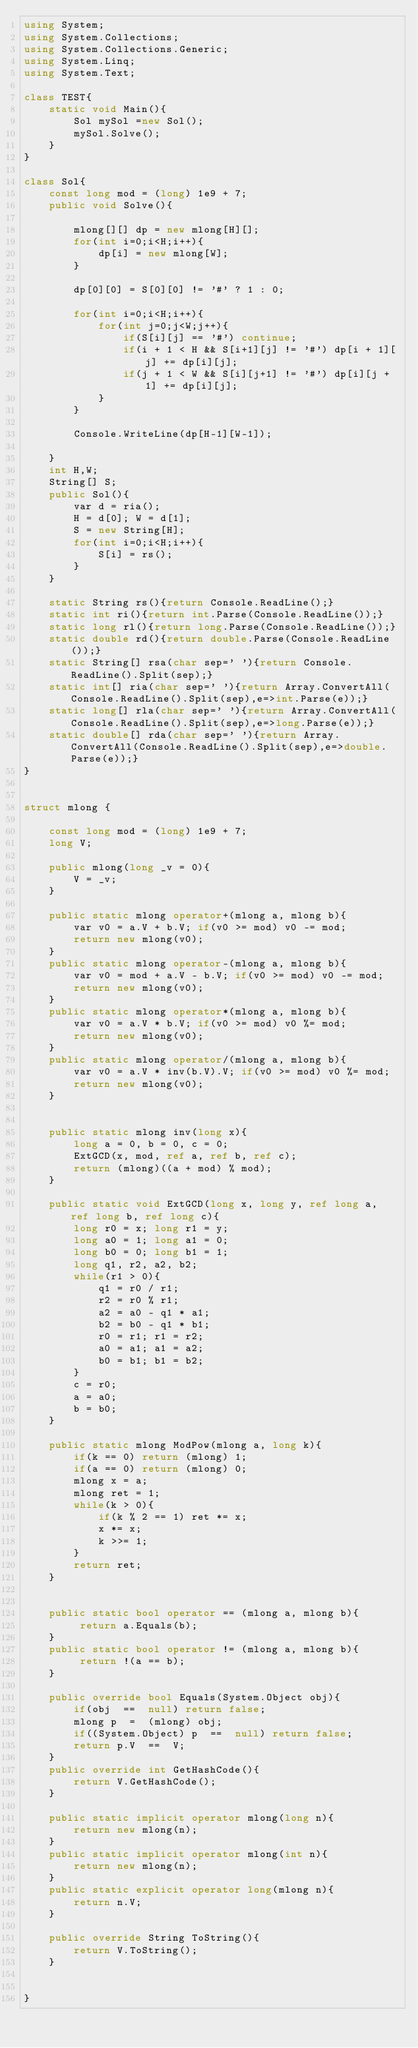<code> <loc_0><loc_0><loc_500><loc_500><_C#_>using System;
using System.Collections;
using System.Collections.Generic;
using System.Linq;
using System.Text;

class TEST{
	static void Main(){
		Sol mySol =new Sol();
		mySol.Solve();
	}
}

class Sol{
	const long mod = (long) 1e9 + 7;
	public void Solve(){
		
		mlong[][] dp = new mlong[H][];
		for(int i=0;i<H;i++){
			dp[i] = new mlong[W];
		}
		
		dp[0][0] = S[0][0] != '#' ? 1 : 0;
		
		for(int i=0;i<H;i++){
			for(int j=0;j<W;j++){
				if(S[i][j] == '#') continue;
				if(i + 1 < H && S[i+1][j] != '#') dp[i + 1][j] += dp[i][j];
				if(j + 1 < W && S[i][j+1] != '#') dp[i][j + 1] += dp[i][j];
			}
		}
		
		Console.WriteLine(dp[H-1][W-1]);
		
	}
	int H,W;
	String[] S;
	public Sol(){
		var d = ria();
		H = d[0]; W = d[1];
		S = new String[H];
		for(int i=0;i<H;i++){
			S[i] = rs();
		}
	}

	static String rs(){return Console.ReadLine();}
	static int ri(){return int.Parse(Console.ReadLine());}
	static long rl(){return long.Parse(Console.ReadLine());}
	static double rd(){return double.Parse(Console.ReadLine());}
	static String[] rsa(char sep=' '){return Console.ReadLine().Split(sep);}
	static int[] ria(char sep=' '){return Array.ConvertAll(Console.ReadLine().Split(sep),e=>int.Parse(e));}
	static long[] rla(char sep=' '){return Array.ConvertAll(Console.ReadLine().Split(sep),e=>long.Parse(e));}
	static double[] rda(char sep=' '){return Array.ConvertAll(Console.ReadLine().Split(sep),e=>double.Parse(e));}
}


struct mlong {
	
	const long mod = (long) 1e9 + 7;
	long V;
	
	public mlong(long _v = 0){
		V = _v;
	}
	
	public static mlong operator+(mlong a, mlong b){
		var v0 = a.V + b.V; if(v0 >= mod) v0 -= mod;
		return new mlong(v0);
	}
	public static mlong operator-(mlong a, mlong b){
		var v0 = mod + a.V - b.V; if(v0 >= mod) v0 -= mod;
		return new mlong(v0);
	}
	public static mlong operator*(mlong a, mlong b){
		var v0 = a.V * b.V; if(v0 >= mod) v0 %= mod;
		return new mlong(v0);
	}
	public static mlong operator/(mlong a, mlong b){
		var v0 = a.V * inv(b.V).V; if(v0 >= mod) v0 %= mod;
		return new mlong(v0);
	}
	
	
	public static mlong inv(long x){
		long a = 0, b = 0, c = 0;
		ExtGCD(x, mod, ref a, ref b, ref c);
		return (mlong)((a + mod) % mod);
	}
	
	public static void ExtGCD(long x, long y, ref long a, ref long b, ref long c){
		long r0 = x; long r1 = y;
		long a0 = 1; long a1 = 0;
		long b0 = 0; long b1 = 1;
		long q1, r2, a2, b2;
		while(r1 > 0){
			q1 = r0 / r1;
			r2 = r0 % r1;
			a2 = a0 - q1 * a1;
			b2 = b0 - q1 * b1;
			r0 = r1; r1 = r2;
			a0 = a1; a1 = a2;
			b0 = b1; b1 = b2;
		}
		c = r0;
		a = a0;
		b = b0;
	}
	
	public static mlong ModPow(mlong a, long k){
		if(k == 0) return (mlong) 1;
		if(a == 0) return (mlong) 0;
		mlong x = a;
		mlong ret = 1;
		while(k > 0){
			if(k % 2 == 1) ret *= x;
			x *= x;
			k >>= 1;
		}
		return ret;
	}
	
	
	public static bool operator == (mlong a, mlong b){
		 return a.Equals(b);
	}
	public static bool operator != (mlong a, mlong b){
		 return !(a == b);
	}
	
	public override bool Equals(System.Object obj){
		if(obj  ==  null) return false;
		mlong p  =  (mlong) obj;
		if((System.Object) p  ==  null) return false;
		return p.V  ==  V;
	}
	public override int GetHashCode(){
		return V.GetHashCode();
	}
	
	public static implicit operator mlong(long n){
		return new mlong(n);
	}
	public static implicit operator mlong(int n){
		return new mlong(n);
	}
	public static explicit operator long(mlong n){
		return n.V;
	}
	
	public override String ToString(){
		return V.ToString();
	}
	
	
}</code> 